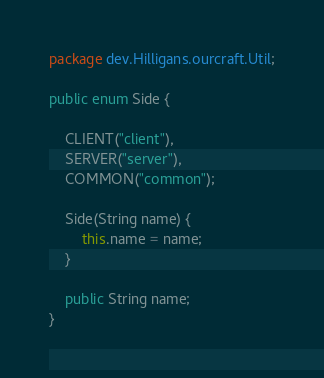Convert code to text. <code><loc_0><loc_0><loc_500><loc_500><_Java_>package dev.Hilligans.ourcraft.Util;

public enum Side {

    CLIENT("client"),
    SERVER("server"),
    COMMON("common");

    Side(String name) {
        this.name = name;
    }

    public String name;
}
</code> 